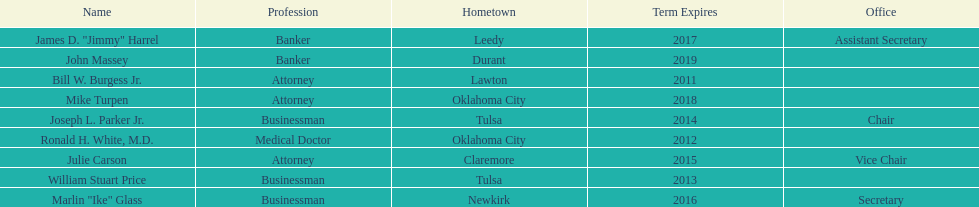What is the total number of state regents who are attorneys? 3. 